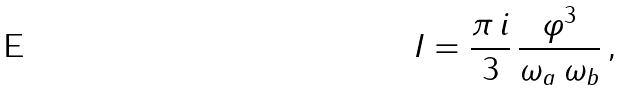<formula> <loc_0><loc_0><loc_500><loc_500>I = \frac { \pi \, i } { 3 } \, \frac { \varphi ^ { 3 } } { \omega _ { a } \, \omega _ { b } } \, ,</formula> 